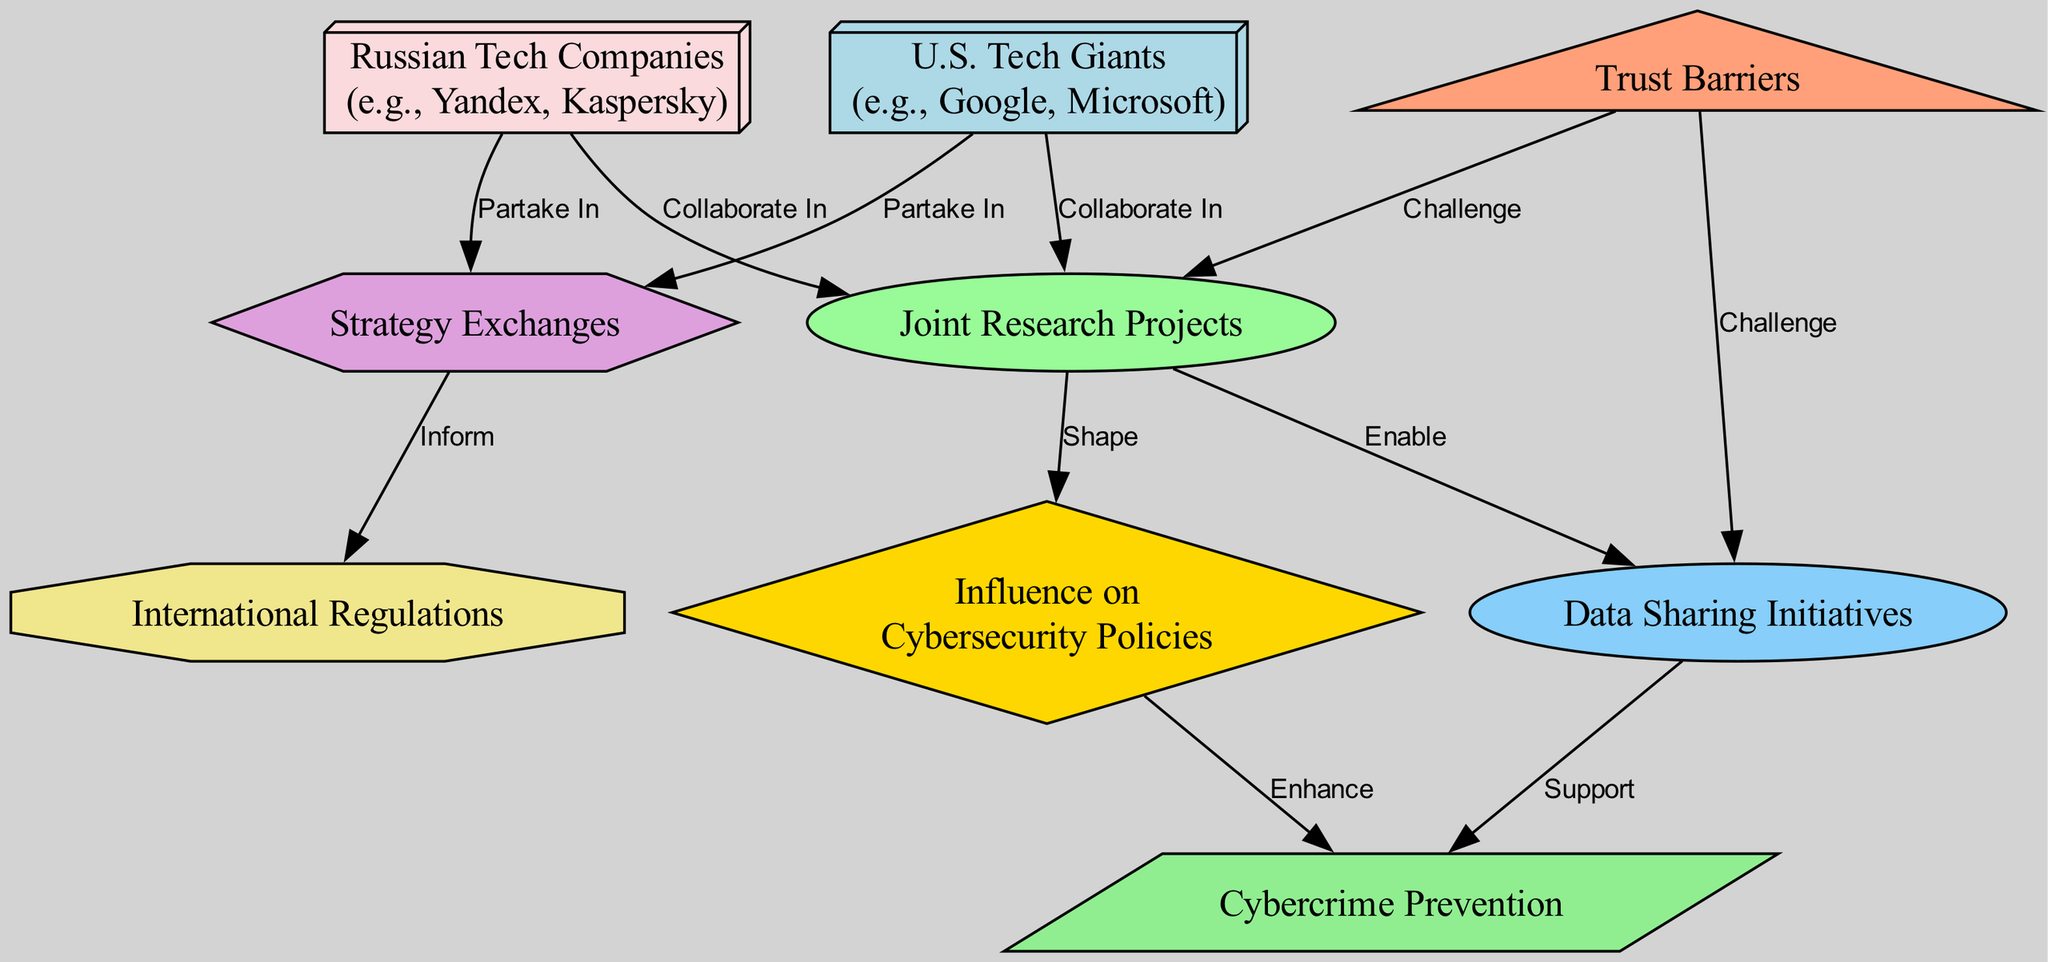What are the U.S. Tech Giants collaborating in? The U.S. Tech Giants node has a direct edge to the Joint Research Projects node, indicating that they collaborate in joint research projects.
Answer: Joint Research Projects How many edges connect to the Cybersecurity Policies node? The Cybersecurity Policies node has two incoming edges: one from Joint Research Projects (shaping policies) and one from Cybercrime Prevention (enhancing policies). Therefore, there are two edges connecting to this node.
Answer: 2 What do Strategy Exchanges inform? The Strategy Exchanges node has a direct edge to the International Regulations node, meaning it informs international regulations.
Answer: International Regulations What challenges the Data Sharing Initiatives? The Data Sharing Initiatives node has a direct edge coming from the Trust Barriers node, which indicates that trust barriers challenge data sharing initiatives.
Answer: Trust Barriers What enhances Cybercrime Prevention? Cybercrime Prevention has two incoming edges: one from Cybersecurity Policies (enhancing it) and one from Data Sharing Initiatives (supporting it). This shows that both contribute to enhancing cybercrime prevention.
Answer: Cybersecurity Policies and Data Sharing Initiatives Which nodes collaborate in Joint Research Projects? Both U.S. Tech Giants and Russian Tech Companies have edges pointing to the Joint Research Projects node, indicating that they both collaborate in this area.
Answer: U.S. Tech Giants and Russian Tech Companies What is shaped by Joint Research Projects? The Joint Research Projects node has a direct edge leading to the Cybersecurity Policies node, meaning that these projects shape cybersecurity policies.
Answer: Cybersecurity Policies What supports Cybercrime Prevention? The Cybercrime Prevention node has incoming edges from two sources: Data Sharing Initiatives and Cybersecurity Policies, indicating that these both provide support.
Answer: Data Sharing Initiatives How do Trust Barriers relate to Joint Research Projects? The Trust Barriers node has a direct edge pointing to the Joint Research Projects node, indicating that trust barriers challenge these collaborative projects.
Answer: Challenge 